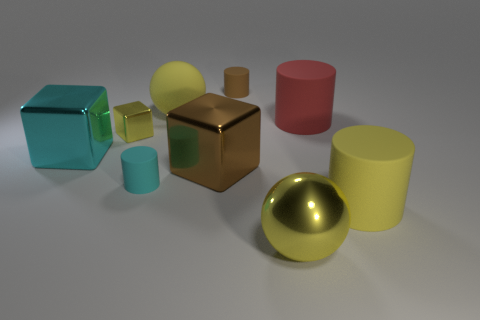Subtract all large yellow cylinders. How many cylinders are left? 3 Subtract 1 cubes. How many cubes are left? 2 Subtract all cyan cylinders. How many cylinders are left? 3 Add 1 tiny red cylinders. How many objects exist? 10 Subtract all gray cylinders. Subtract all red blocks. How many cylinders are left? 4 Subtract all blocks. How many objects are left? 6 Add 6 brown metal blocks. How many brown metal blocks are left? 7 Add 6 spheres. How many spheres exist? 8 Subtract 1 red cylinders. How many objects are left? 8 Subtract all yellow shiny spheres. Subtract all red rubber objects. How many objects are left? 7 